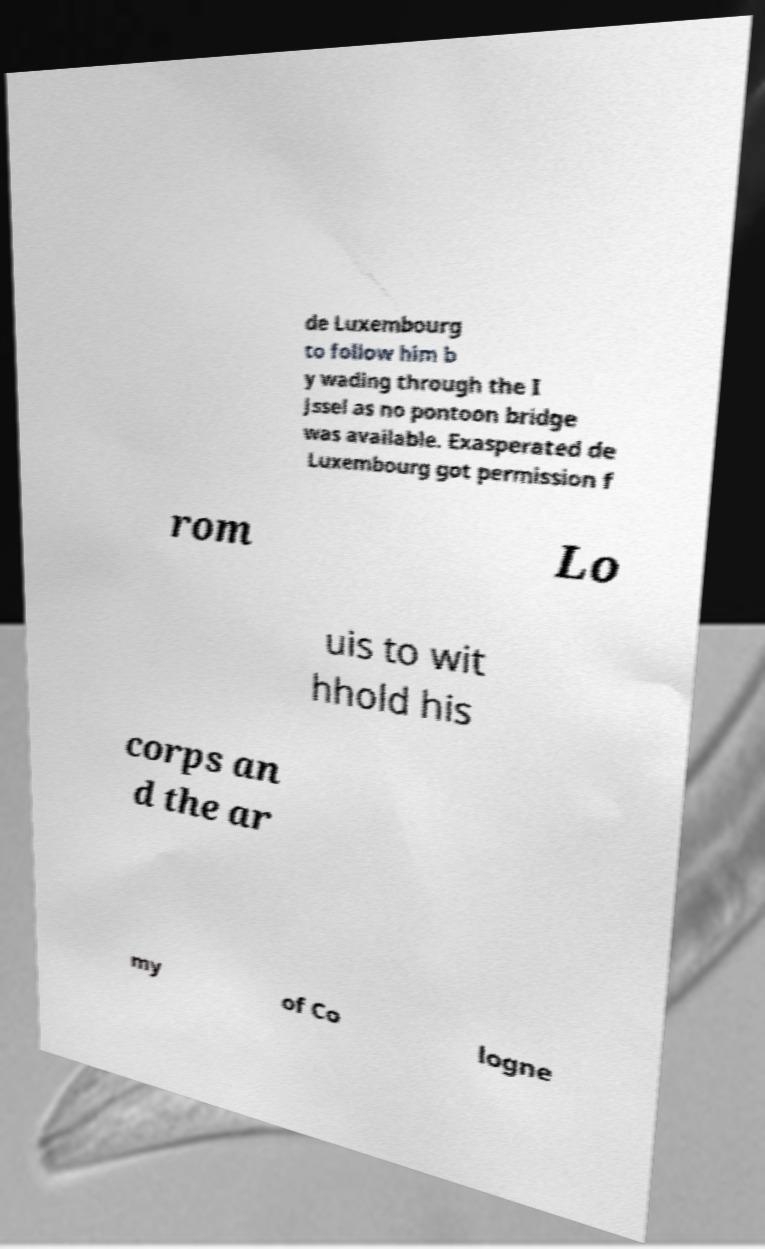Please identify and transcribe the text found in this image. de Luxembourg to follow him b y wading through the I Jssel as no pontoon bridge was available. Exasperated de Luxembourg got permission f rom Lo uis to wit hhold his corps an d the ar my of Co logne 